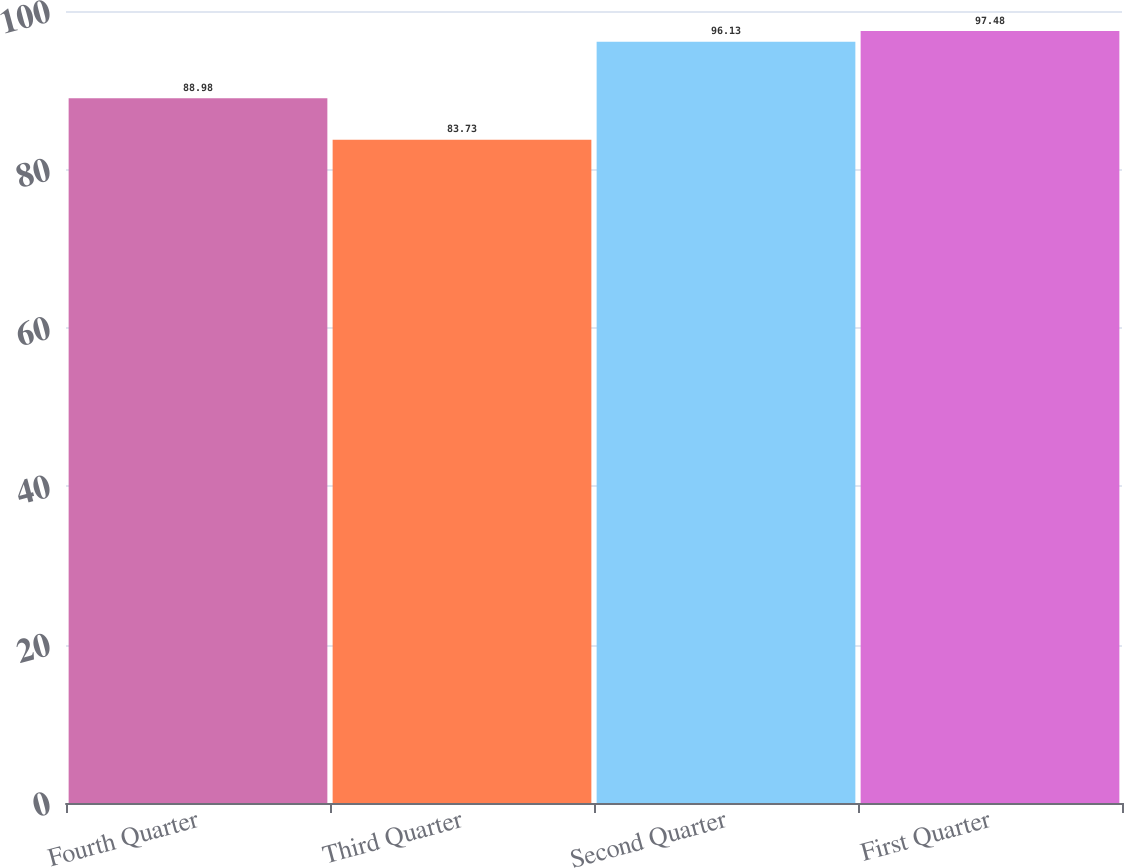Convert chart to OTSL. <chart><loc_0><loc_0><loc_500><loc_500><bar_chart><fcel>Fourth Quarter<fcel>Third Quarter<fcel>Second Quarter<fcel>First Quarter<nl><fcel>88.98<fcel>83.73<fcel>96.13<fcel>97.48<nl></chart> 